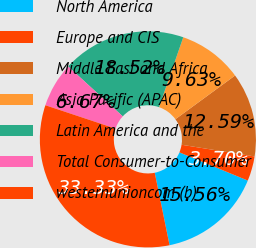<chart> <loc_0><loc_0><loc_500><loc_500><pie_chart><fcel>North America<fcel>Europe and CIS<fcel>Middle East and Africa<fcel>Asia Pacific (APAC)<fcel>Latin America and the<fcel>Total Consumer-to-Consumer<fcel>westernunioncom (b)<nl><fcel>15.56%<fcel>3.7%<fcel>12.59%<fcel>9.63%<fcel>18.52%<fcel>6.67%<fcel>33.33%<nl></chart> 